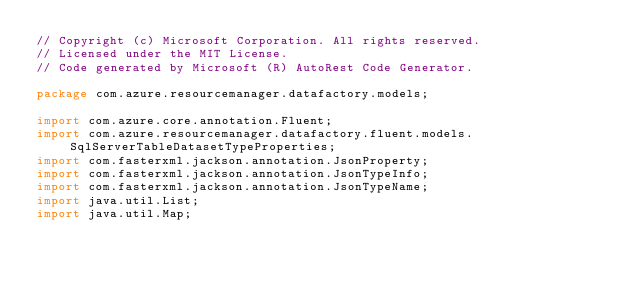<code> <loc_0><loc_0><loc_500><loc_500><_Java_>// Copyright (c) Microsoft Corporation. All rights reserved.
// Licensed under the MIT License.
// Code generated by Microsoft (R) AutoRest Code Generator.

package com.azure.resourcemanager.datafactory.models;

import com.azure.core.annotation.Fluent;
import com.azure.resourcemanager.datafactory.fluent.models.SqlServerTableDatasetTypeProperties;
import com.fasterxml.jackson.annotation.JsonProperty;
import com.fasterxml.jackson.annotation.JsonTypeInfo;
import com.fasterxml.jackson.annotation.JsonTypeName;
import java.util.List;
import java.util.Map;
</code> 